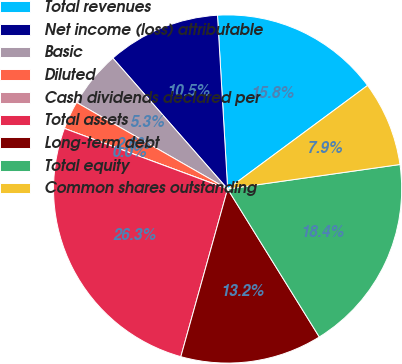<chart> <loc_0><loc_0><loc_500><loc_500><pie_chart><fcel>Total revenues<fcel>Net income (loss) attributable<fcel>Basic<fcel>Diluted<fcel>Cash dividends declared per<fcel>Total assets<fcel>Long-term debt<fcel>Total equity<fcel>Common shares outstanding<nl><fcel>15.79%<fcel>10.53%<fcel>5.26%<fcel>2.63%<fcel>0.0%<fcel>26.32%<fcel>13.16%<fcel>18.42%<fcel>7.89%<nl></chart> 